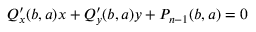<formula> <loc_0><loc_0><loc_500><loc_500>Q _ { x } ^ { \prime } ( b , a ) x + Q _ { y } ^ { \prime } ( b , a ) y + P _ { n - 1 } ( b , a ) = 0</formula> 